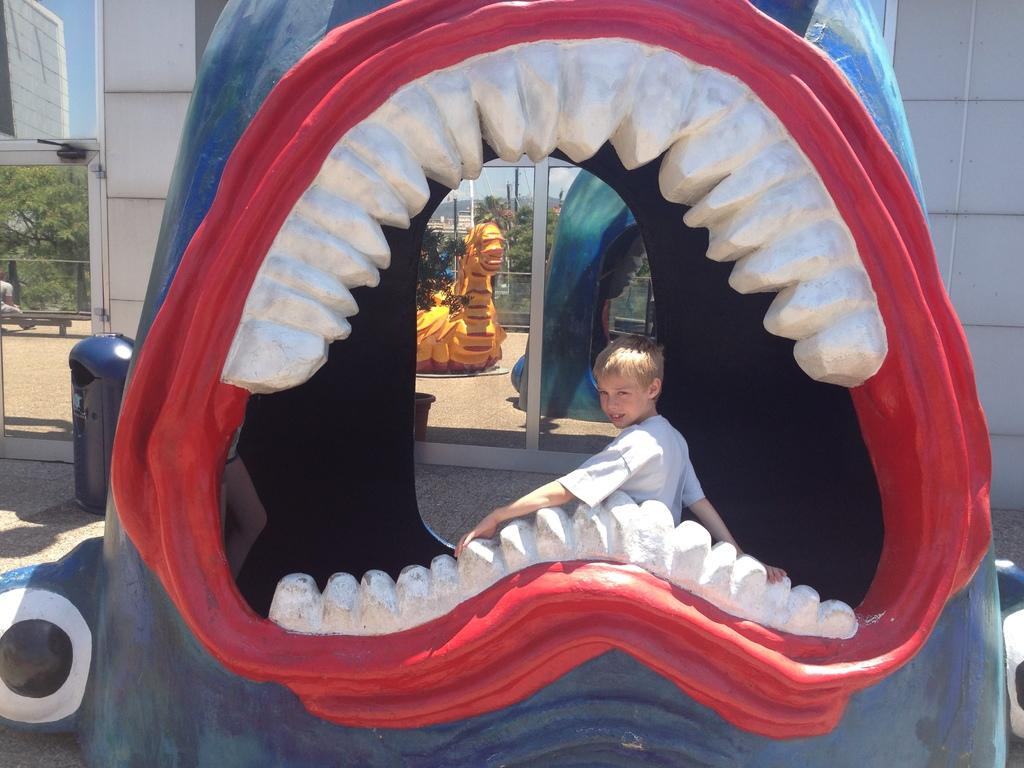What is the main subject of the image? The main subject of the image is a kid. What is the kid doing in the image? The kid is smiling and posing for the camera. Where is the kid positioned in the image? The kid is positioned in the open mouth of a shark statue. What type of sponge can be seen in the image? There is no sponge present in the image. Can you describe the zipper on the kid's clothing in the image? There is no mention of a zipper on the kid's clothing in the provided facts. What color is the yarn used to create the shark statue in the image? The provided facts do not mention the material or color of the shark statue. 